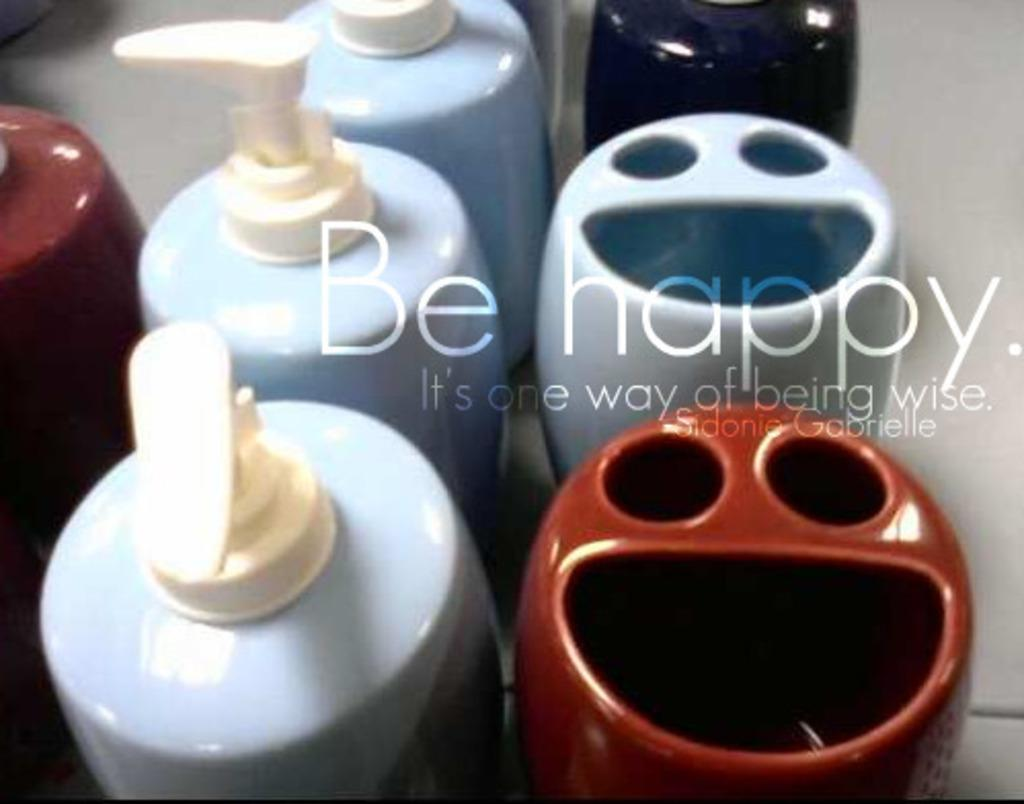What can be seen in the image that is used for holding liquids? There are bottles in the image that are used for holding liquids. What other objects can be seen in the image besides the bottles? There are other objects in the image, but their specific details are not mentioned in the provided facts. Is there any additional information about the image itself? Yes, there is a watermark on the image. What type of flowers can be seen growing around the ring in the image? There is no mention of flowers or a ring in the provided facts, so we cannot answer this question based on the image. 